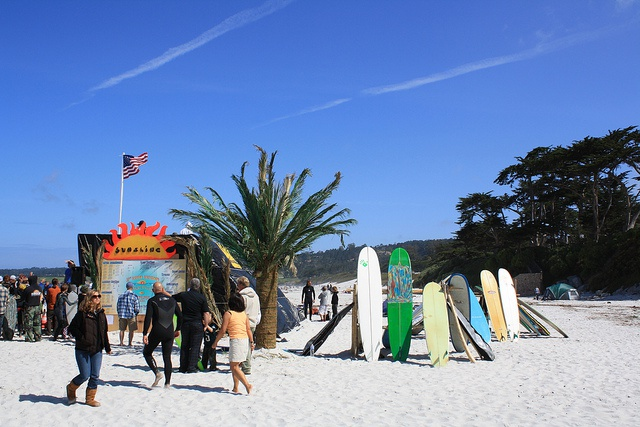Describe the objects in this image and their specific colors. I can see people in blue, black, gray, and lightgray tones, people in blue, black, lightgray, maroon, and navy tones, people in blue, black, gray, and maroon tones, surfboard in blue, white, darkgray, gray, and lightblue tones, and surfboard in blue, green, teal, and darkgreen tones in this image. 